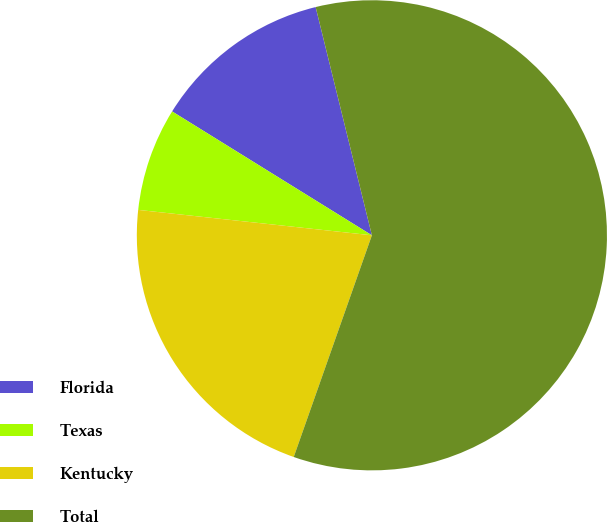Convert chart. <chart><loc_0><loc_0><loc_500><loc_500><pie_chart><fcel>Florida<fcel>Texas<fcel>Kentucky<fcel>Total<nl><fcel>12.32%<fcel>7.11%<fcel>21.33%<fcel>59.24%<nl></chart> 